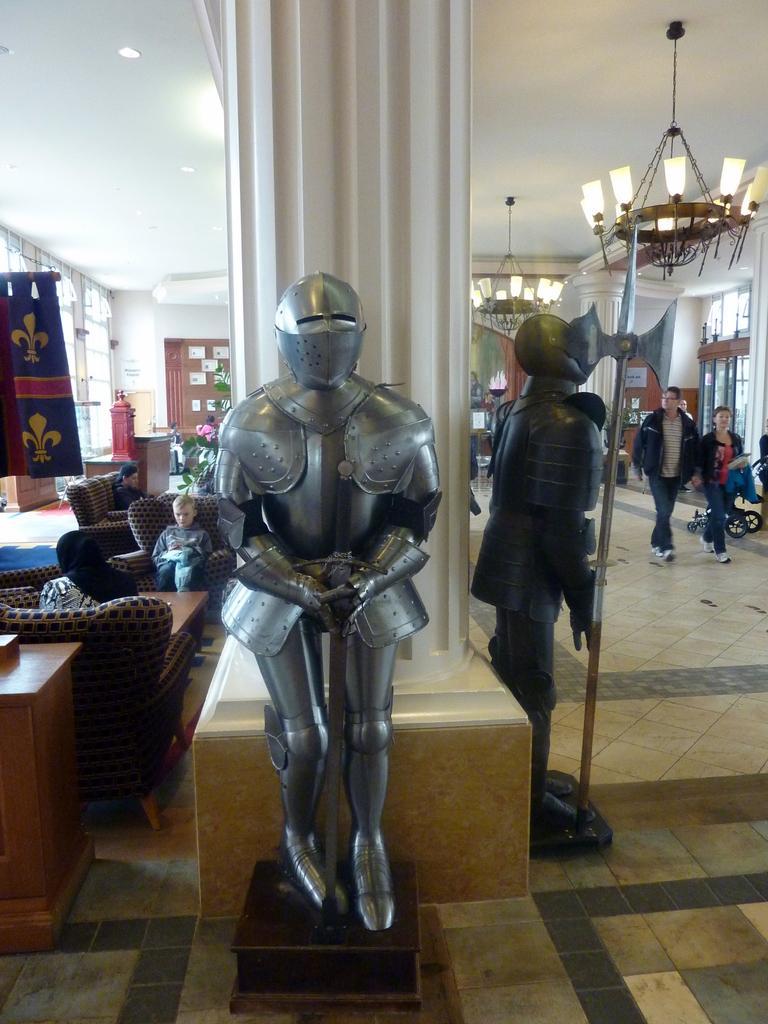Could you give a brief overview of what you see in this image? In this picture I can see there are armor at the pillar, there is a man and a woman walking on to right and there is a boy sitting in the chair at left and there is a person sitting on the couch behind the boy, there is a plant, the flag and there are windows at the left and right side. 